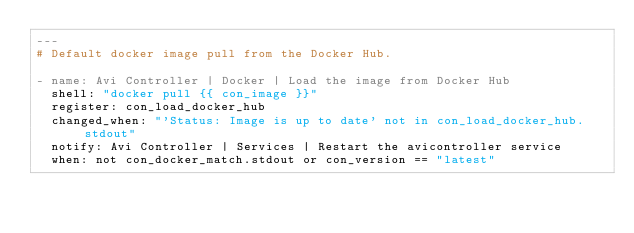<code> <loc_0><loc_0><loc_500><loc_500><_YAML_>---
# Default docker image pull from the Docker Hub.

- name: Avi Controller | Docker | Load the image from Docker Hub
  shell: "docker pull {{ con_image }}"
  register: con_load_docker_hub
  changed_when: "'Status: Image is up to date' not in con_load_docker_hub.stdout"
  notify: Avi Controller | Services | Restart the avicontroller service
  when: not con_docker_match.stdout or con_version == "latest"
</code> 